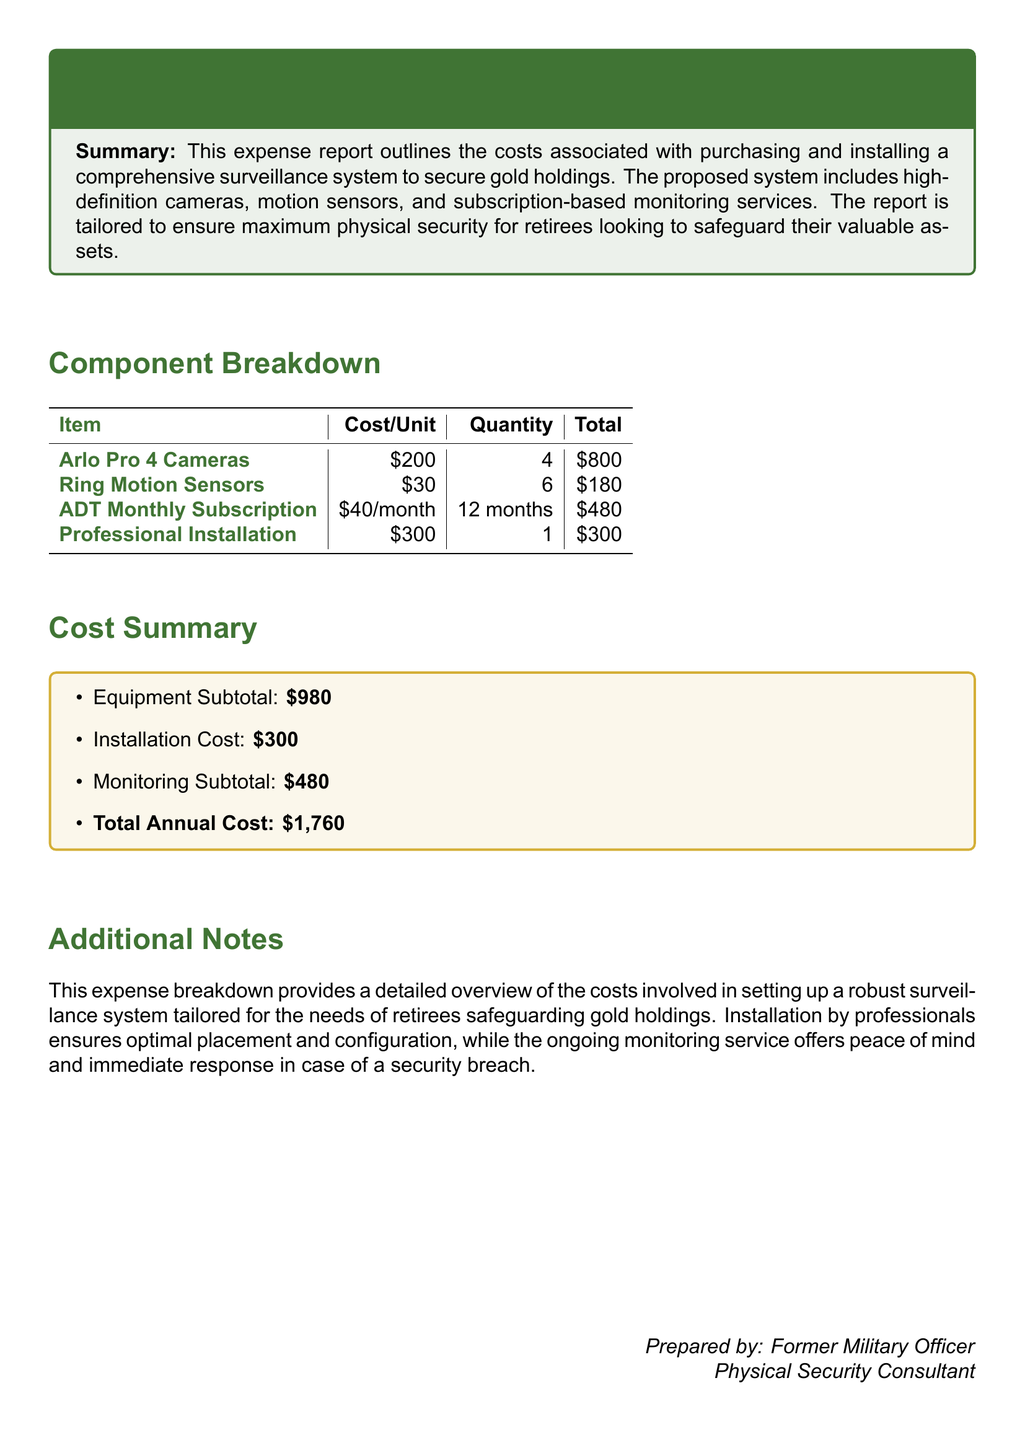What is the total cost of the Arlo Pro 4 Cameras? The total cost of the Arlo Pro 4 Cameras is calculated by multiplying the cost per unit by the quantity. Thus, \$200 * 4 = \$800.
Answer: \$800 How many Ring Motion Sensors were purchased? The quantity of Ring Motion Sensors purchased is explicitly stated in the breakdown table.
Answer: 6 What is the monthly cost of the ADT Subscription? The monthly cost for the ADT Subscription is specified in the document as \$40.
Answer: \$40 What is the professional installation cost? The cost for professional installation of the surveillance system is listed in the document as a single amount.
Answer: \$300 What is the total annual cost of the surveillance system? The total annual cost is the sum of all components listed in the cost summary: Equipment Subtotal, Installation Cost, and Monitoring Subtotal, totaling \$1,760.
Answer: \$1,760 What is the equipment subtotal? The equipment subtotal is identified in the cost summary section and calculated from the equipment costs only.
Answer: \$980 Which camera brand is mentioned in the report? The report explicitly states the brand being used for the cameras.
Answer: Arlo What type of motion sensor is included in the installation? The type of motion sensor is mentioned in the breakdown of costs, specifically identifying the brand.
Answer: Ring What does the ongoing monitoring service provide? The ongoing monitoring service is described in the additional notes and highlights its purpose.
Answer: Peace of mind What recommendation comes from the professional installation? The benefits of professional installation are stated to include optimal placement and configuration.
Answer: Optimal placement and configuration 